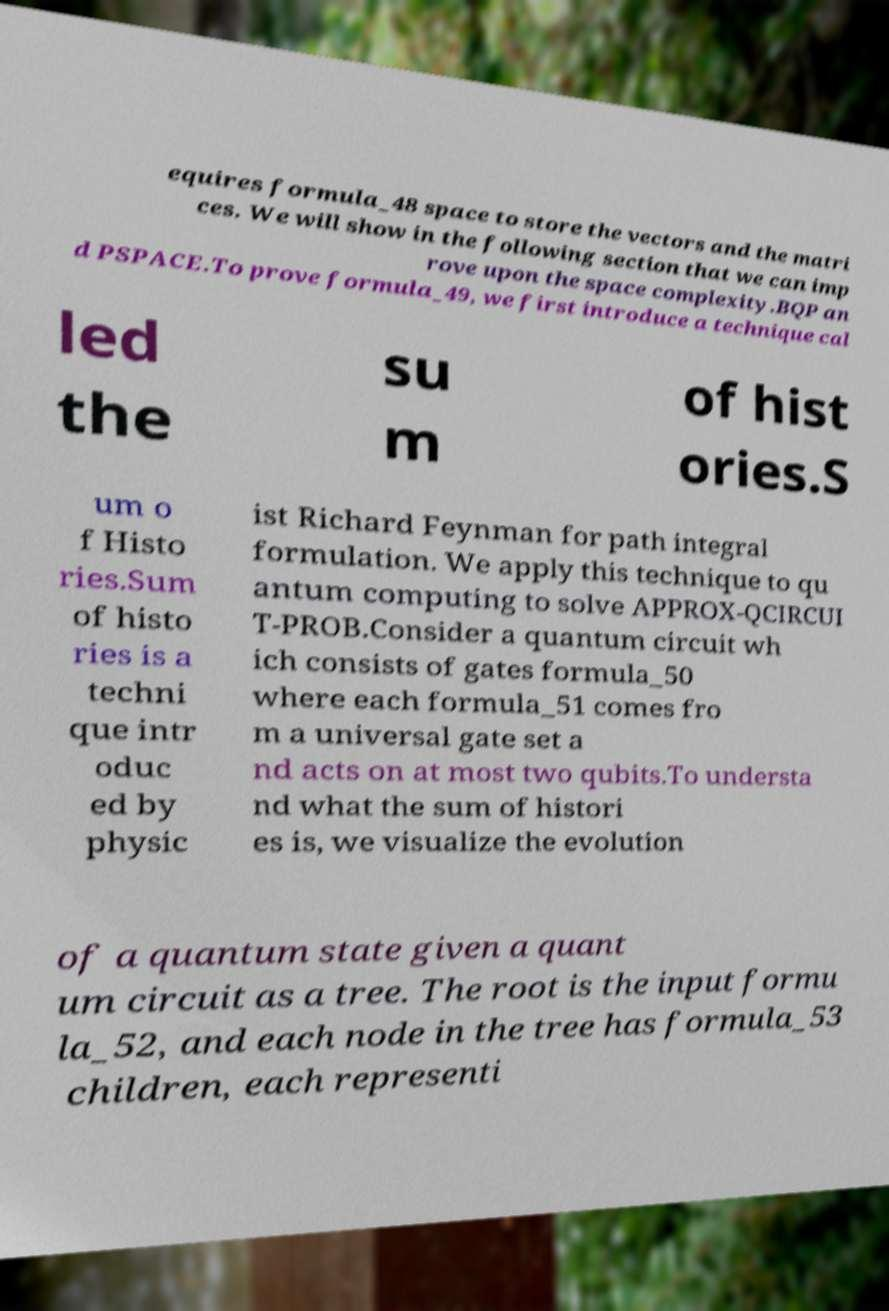There's text embedded in this image that I need extracted. Can you transcribe it verbatim? equires formula_48 space to store the vectors and the matri ces. We will show in the following section that we can imp rove upon the space complexity.BQP an d PSPACE.To prove formula_49, we first introduce a technique cal led the su m of hist ories.S um o f Histo ries.Sum of histo ries is a techni que intr oduc ed by physic ist Richard Feynman for path integral formulation. We apply this technique to qu antum computing to solve APPROX-QCIRCUI T-PROB.Consider a quantum circuit wh ich consists of gates formula_50 where each formula_51 comes fro m a universal gate set a nd acts on at most two qubits.To understa nd what the sum of histori es is, we visualize the evolution of a quantum state given a quant um circuit as a tree. The root is the input formu la_52, and each node in the tree has formula_53 children, each representi 